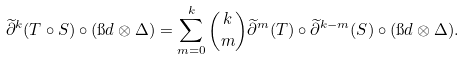Convert formula to latex. <formula><loc_0><loc_0><loc_500><loc_500>\widetilde { \partial } ^ { k } ( T \circ S ) \circ ( \i d \otimes \Delta ) = \sum _ { m = 0 } ^ { k } \binom { k } { m } \widetilde { \partial } ^ { m } ( T ) \circ \widetilde { \partial } ^ { k - m } ( S ) \circ ( \i d \otimes \Delta ) .</formula> 